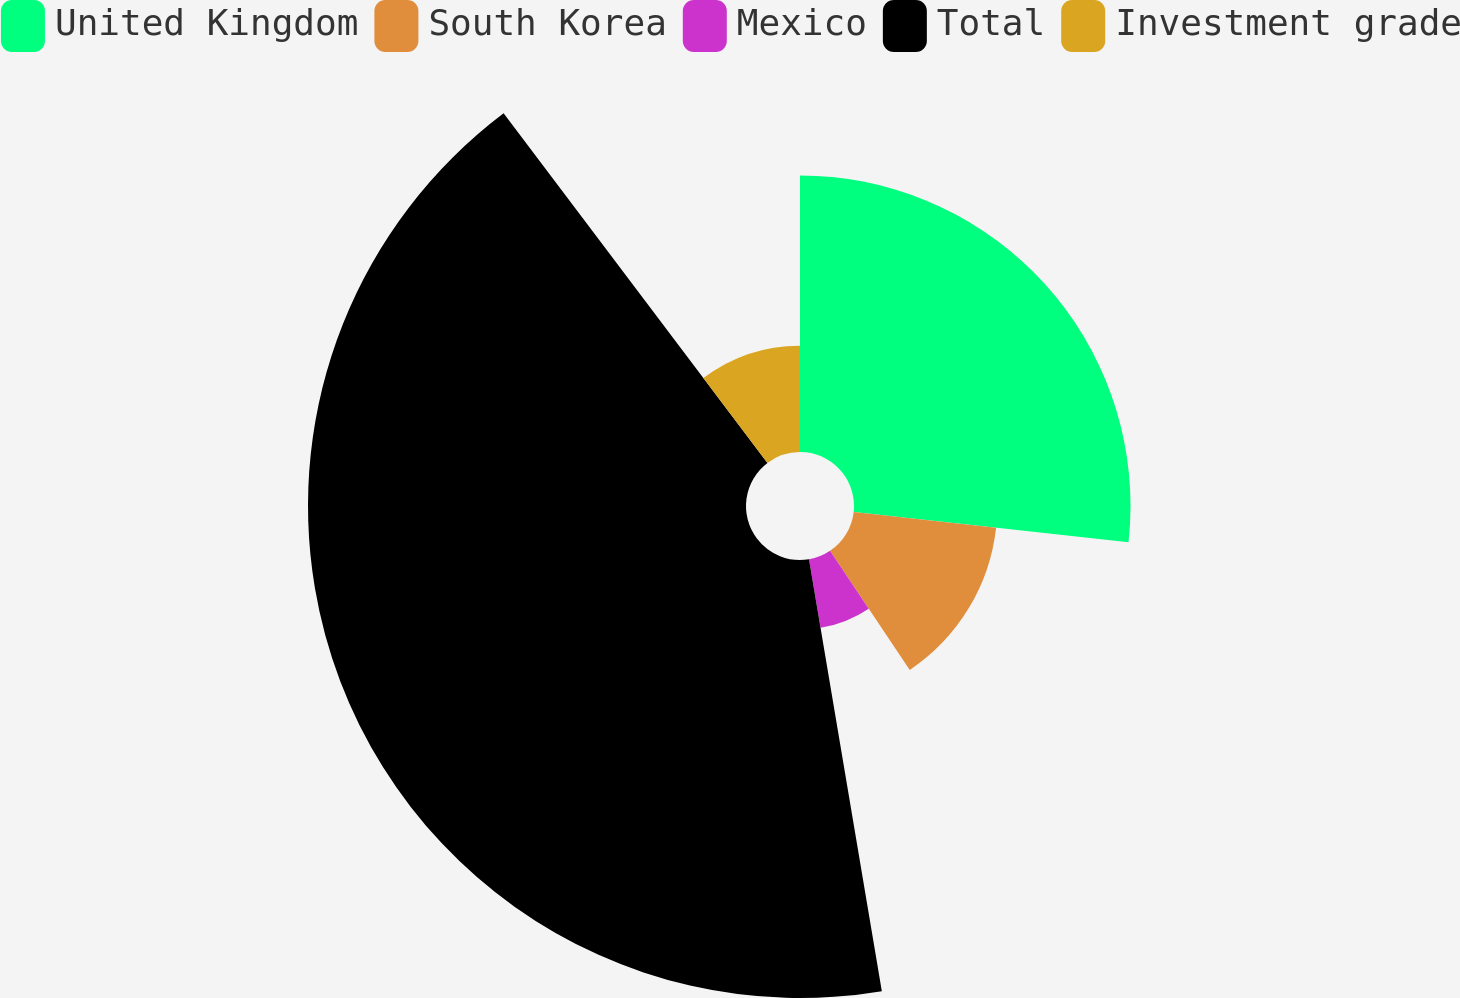Convert chart. <chart><loc_0><loc_0><loc_500><loc_500><pie_chart><fcel>United Kingdom<fcel>South Korea<fcel>Mexico<fcel>Total<fcel>Investment grade<nl><fcel>26.75%<fcel>13.86%<fcel>6.73%<fcel>42.37%<fcel>10.29%<nl></chart> 